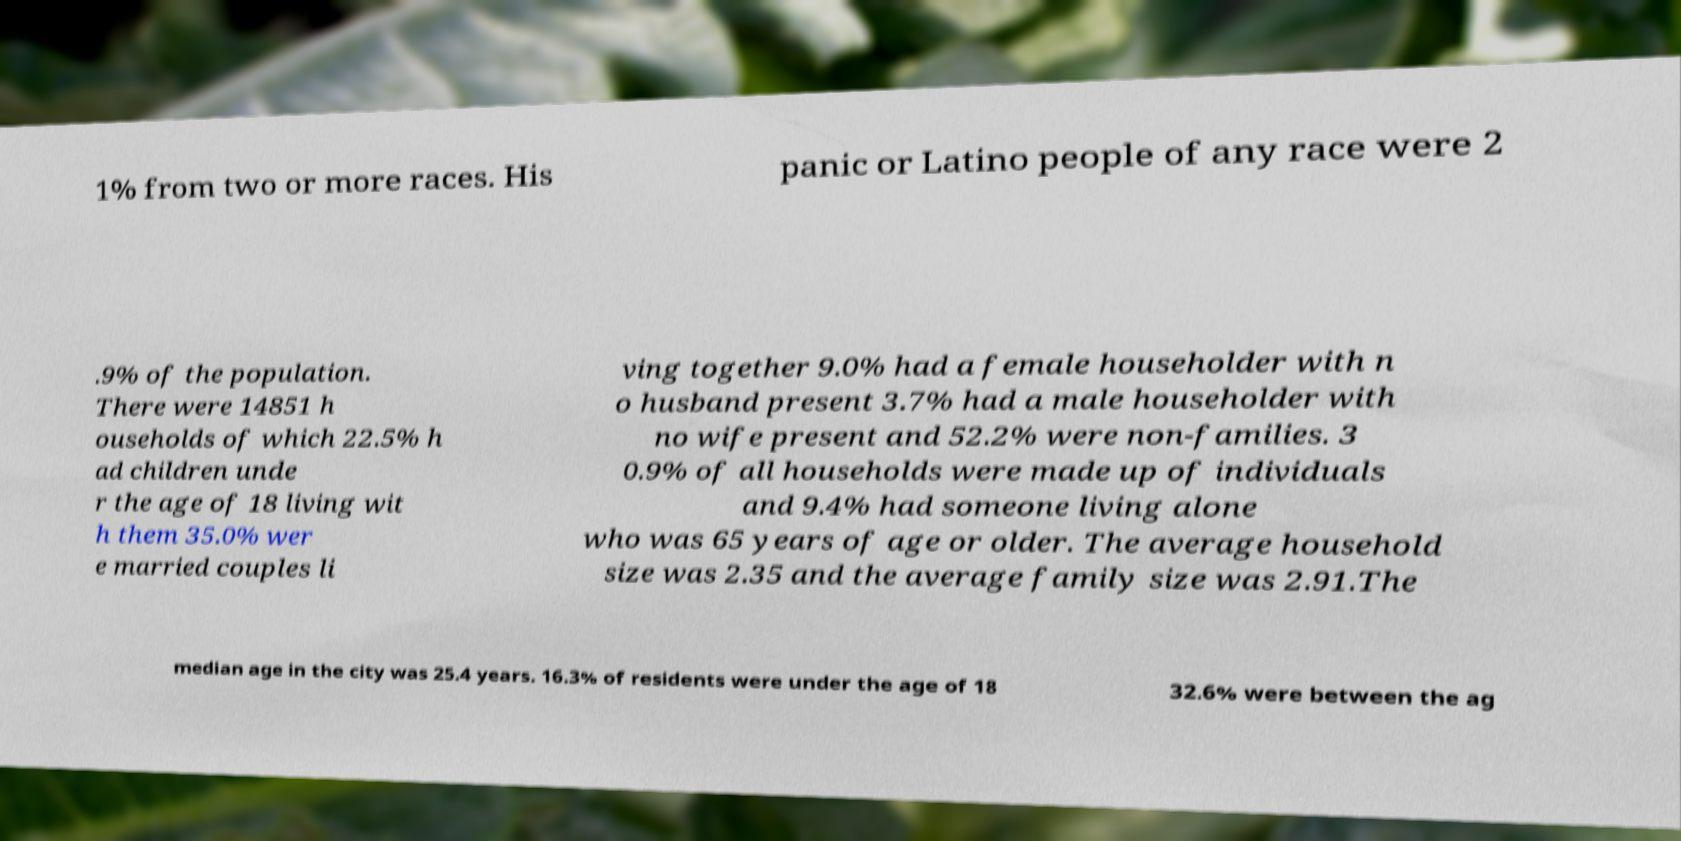There's text embedded in this image that I need extracted. Can you transcribe it verbatim? 1% from two or more races. His panic or Latino people of any race were 2 .9% of the population. There were 14851 h ouseholds of which 22.5% h ad children unde r the age of 18 living wit h them 35.0% wer e married couples li ving together 9.0% had a female householder with n o husband present 3.7% had a male householder with no wife present and 52.2% were non-families. 3 0.9% of all households were made up of individuals and 9.4% had someone living alone who was 65 years of age or older. The average household size was 2.35 and the average family size was 2.91.The median age in the city was 25.4 years. 16.3% of residents were under the age of 18 32.6% were between the ag 